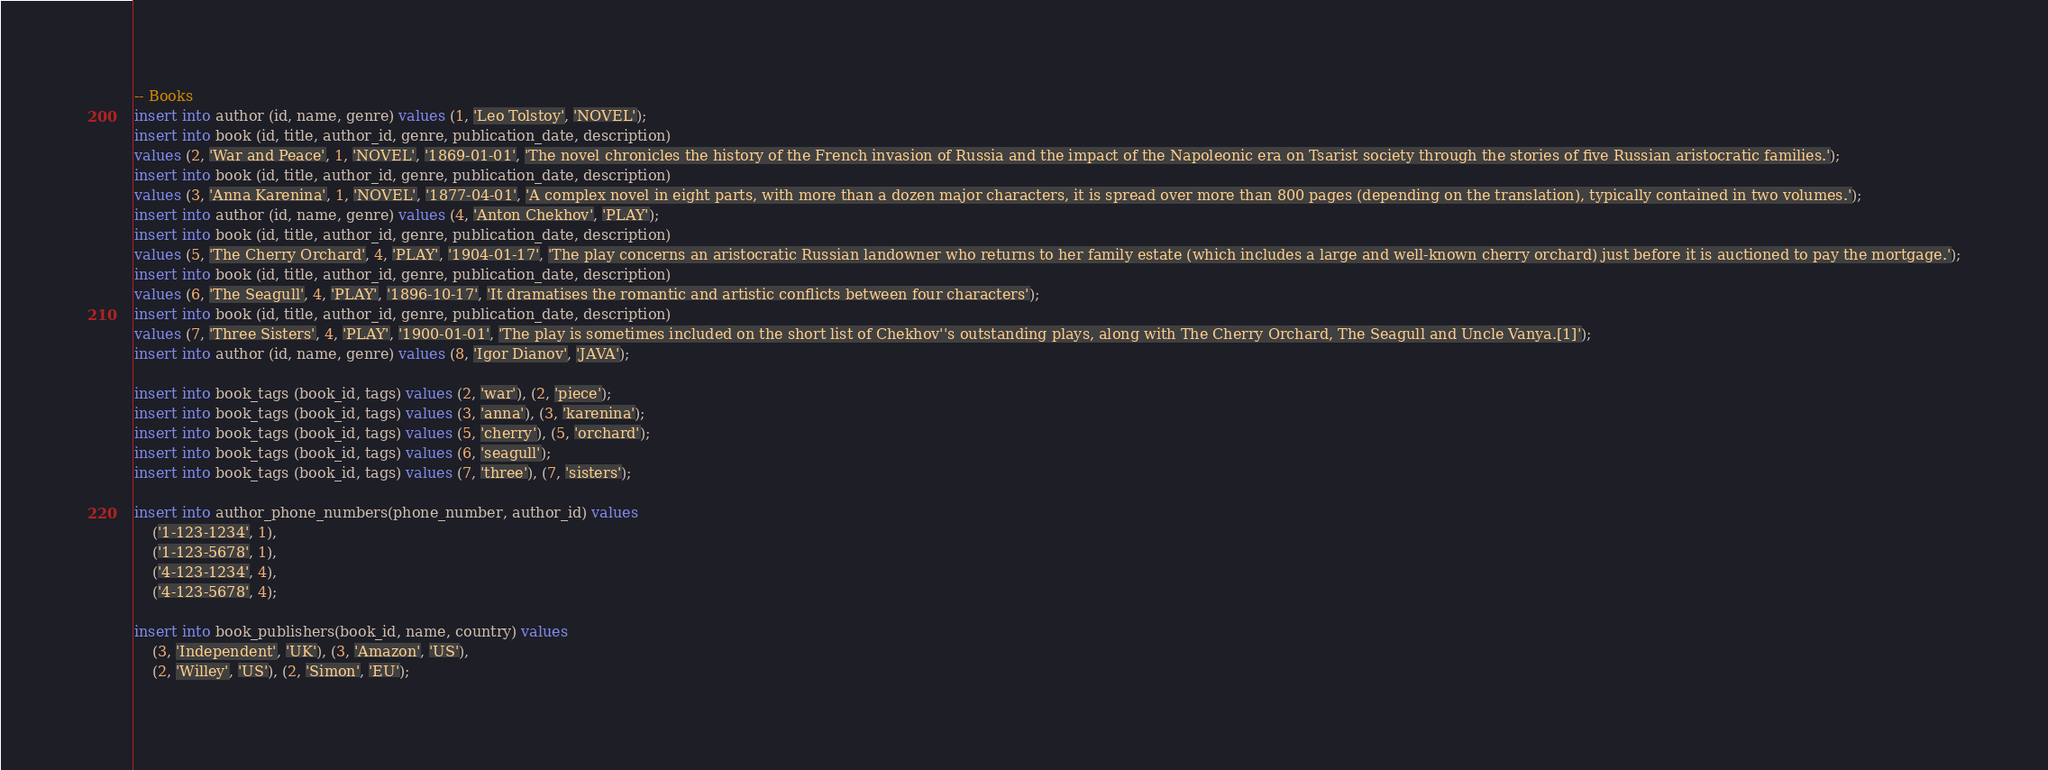Convert code to text. <code><loc_0><loc_0><loc_500><loc_500><_SQL_>-- Books
insert into author (id, name, genre) values (1, 'Leo Tolstoy', 'NOVEL');
insert into book (id, title, author_id, genre, publication_date, description)
values (2, 'War and Peace', 1, 'NOVEL', '1869-01-01', 'The novel chronicles the history of the French invasion of Russia and the impact of the Napoleonic era on Tsarist society through the stories of five Russian aristocratic families.');
insert into book (id, title, author_id, genre, publication_date, description)
values (3, 'Anna Karenina', 1, 'NOVEL', '1877-04-01', 'A complex novel in eight parts, with more than a dozen major characters, it is spread over more than 800 pages (depending on the translation), typically contained in two volumes.');
insert into author (id, name, genre) values (4, 'Anton Chekhov', 'PLAY');
insert into book (id, title, author_id, genre, publication_date, description)
values (5, 'The Cherry Orchard', 4, 'PLAY', '1904-01-17', 'The play concerns an aristocratic Russian landowner who returns to her family estate (which includes a large and well-known cherry orchard) just before it is auctioned to pay the mortgage.');
insert into book (id, title, author_id, genre, publication_date, description)
values (6, 'The Seagull', 4, 'PLAY', '1896-10-17', 'It dramatises the romantic and artistic conflicts between four characters');
insert into book (id, title, author_id, genre, publication_date, description)
values (7, 'Three Sisters', 4, 'PLAY', '1900-01-01', 'The play is sometimes included on the short list of Chekhov''s outstanding plays, along with The Cherry Orchard, The Seagull and Uncle Vanya.[1]');
insert into author (id, name, genre) values (8, 'Igor Dianov', 'JAVA');

insert into book_tags (book_id, tags) values (2, 'war'), (2, 'piece');
insert into book_tags (book_id, tags) values (3, 'anna'), (3, 'karenina');
insert into book_tags (book_id, tags) values (5, 'cherry'), (5, 'orchard');
insert into book_tags (book_id, tags) values (6, 'seagull');
insert into book_tags (book_id, tags) values (7, 'three'), (7, 'sisters');

insert into author_phone_numbers(phone_number, author_id) values
	('1-123-1234', 1),
	('1-123-5678', 1),
	('4-123-1234', 4),
	('4-123-5678', 4);

insert into book_publishers(book_id, name, country) values
	(3, 'Independent', 'UK'), (3, 'Amazon', 'US'),
	(2, 'Willey', 'US'), (2, 'Simon', 'EU');
</code> 